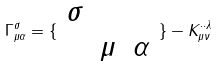<formula> <loc_0><loc_0><loc_500><loc_500>\Gamma ^ { \sigma } _ { \mu \alpha } = \{ \begin{array} { l l l } \sigma & & \\ & \mu & \alpha \end{array} \} - K _ { \mu \nu } ^ { \cdot \cdot \lambda }</formula> 